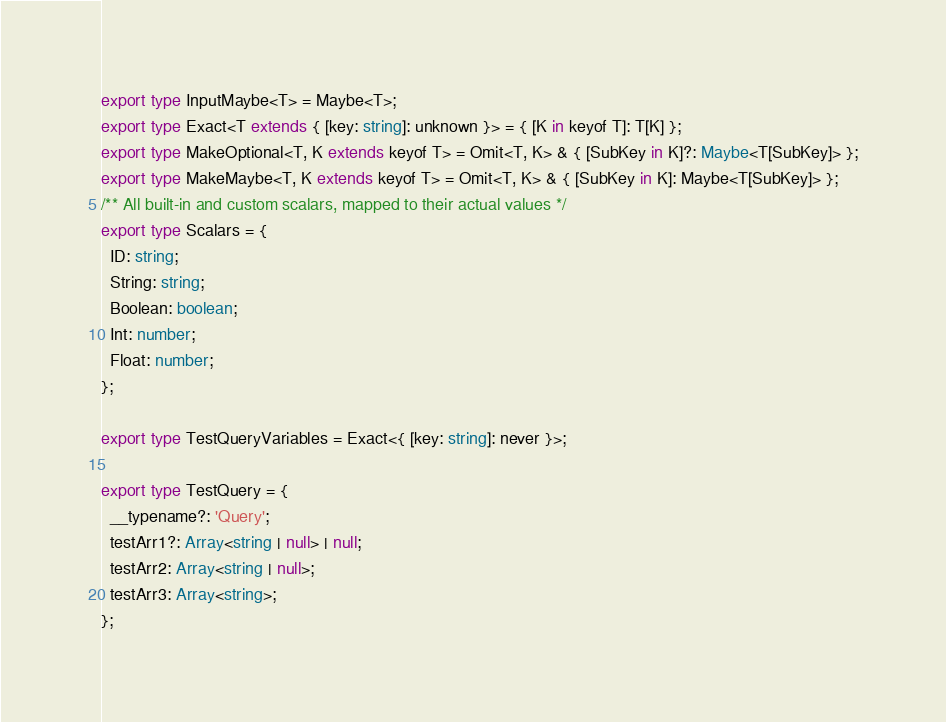<code> <loc_0><loc_0><loc_500><loc_500><_TypeScript_>export type InputMaybe<T> = Maybe<T>;
export type Exact<T extends { [key: string]: unknown }> = { [K in keyof T]: T[K] };
export type MakeOptional<T, K extends keyof T> = Omit<T, K> & { [SubKey in K]?: Maybe<T[SubKey]> };
export type MakeMaybe<T, K extends keyof T> = Omit<T, K> & { [SubKey in K]: Maybe<T[SubKey]> };
/** All built-in and custom scalars, mapped to their actual values */
export type Scalars = {
  ID: string;
  String: string;
  Boolean: boolean;
  Int: number;
  Float: number;
};

export type TestQueryVariables = Exact<{ [key: string]: never }>;

export type TestQuery = {
  __typename?: 'Query';
  testArr1?: Array<string | null> | null;
  testArr2: Array<string | null>;
  testArr3: Array<string>;
};
</code> 